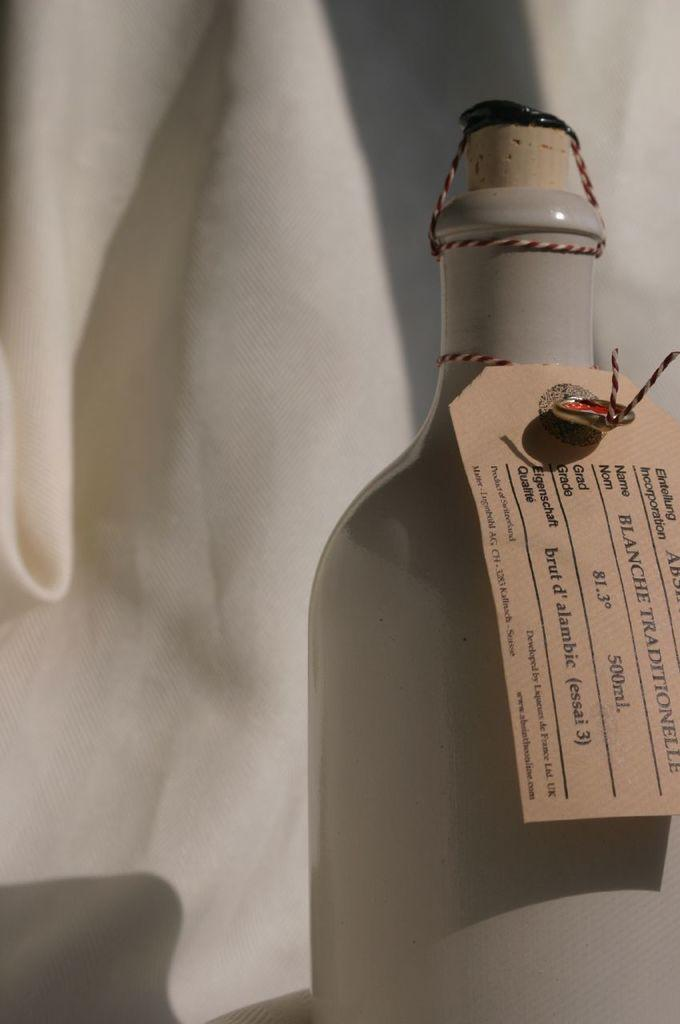<image>
Describe the image concisely. A ceramic bottle is corked and has a tag that says Blanche Traditionelle. 